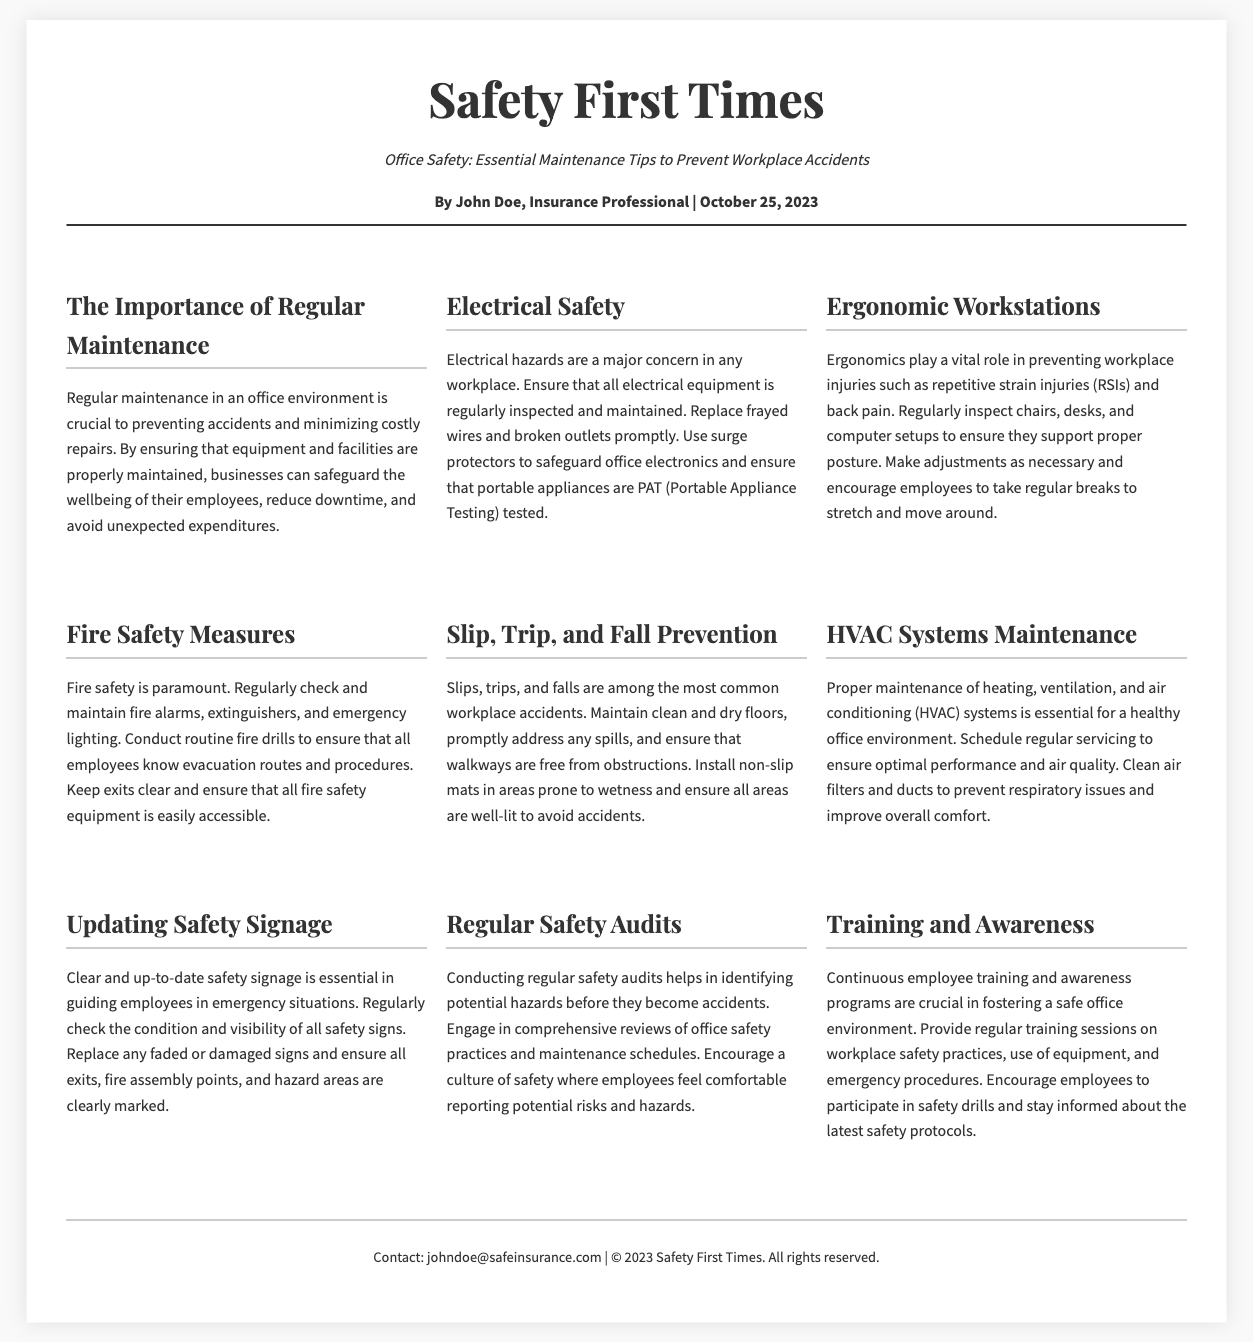What is the title of the document? The title of the document is prominently displayed at the top of the rendered layout.
Answer: Safety First Times Who is the author of the article? The author's name is listed in the author information section below the title.
Answer: John Doe What date was the article published? The publication date is included in the author information section.
Answer: October 25, 2023 What is one of the key topics discussed in the article? The article outlines several topics, each labeled with a section heading.
Answer: Electrical Safety What is the purpose of regular maintenance according to the document? The document states that regular maintenance is crucial for several reasons outlined in the first section.
Answer: Preventing accidents What are two measures mentioned for fire safety? The document lists specific steps to ensure fire safety within the workplace across a dedicated section.
Answer: Check fire alarms, conduct fire drills What is a maintenance tip related to ergonomic workstations? This information is found in the section discussing ergonomics, which includes recommendations for workstation setups.
Answer: Support proper posture Why are safety audits important? The importance of safety audits is explained in a dedicated section, emphasizing their role in hazard identification.
Answer: Identify potential hazards What should be regularly checked to ensure HVAC systems function properly? The HVAC maintenance section outlines specific tasks that should be performed for optimal performance.
Answer: Air filters and ducts 